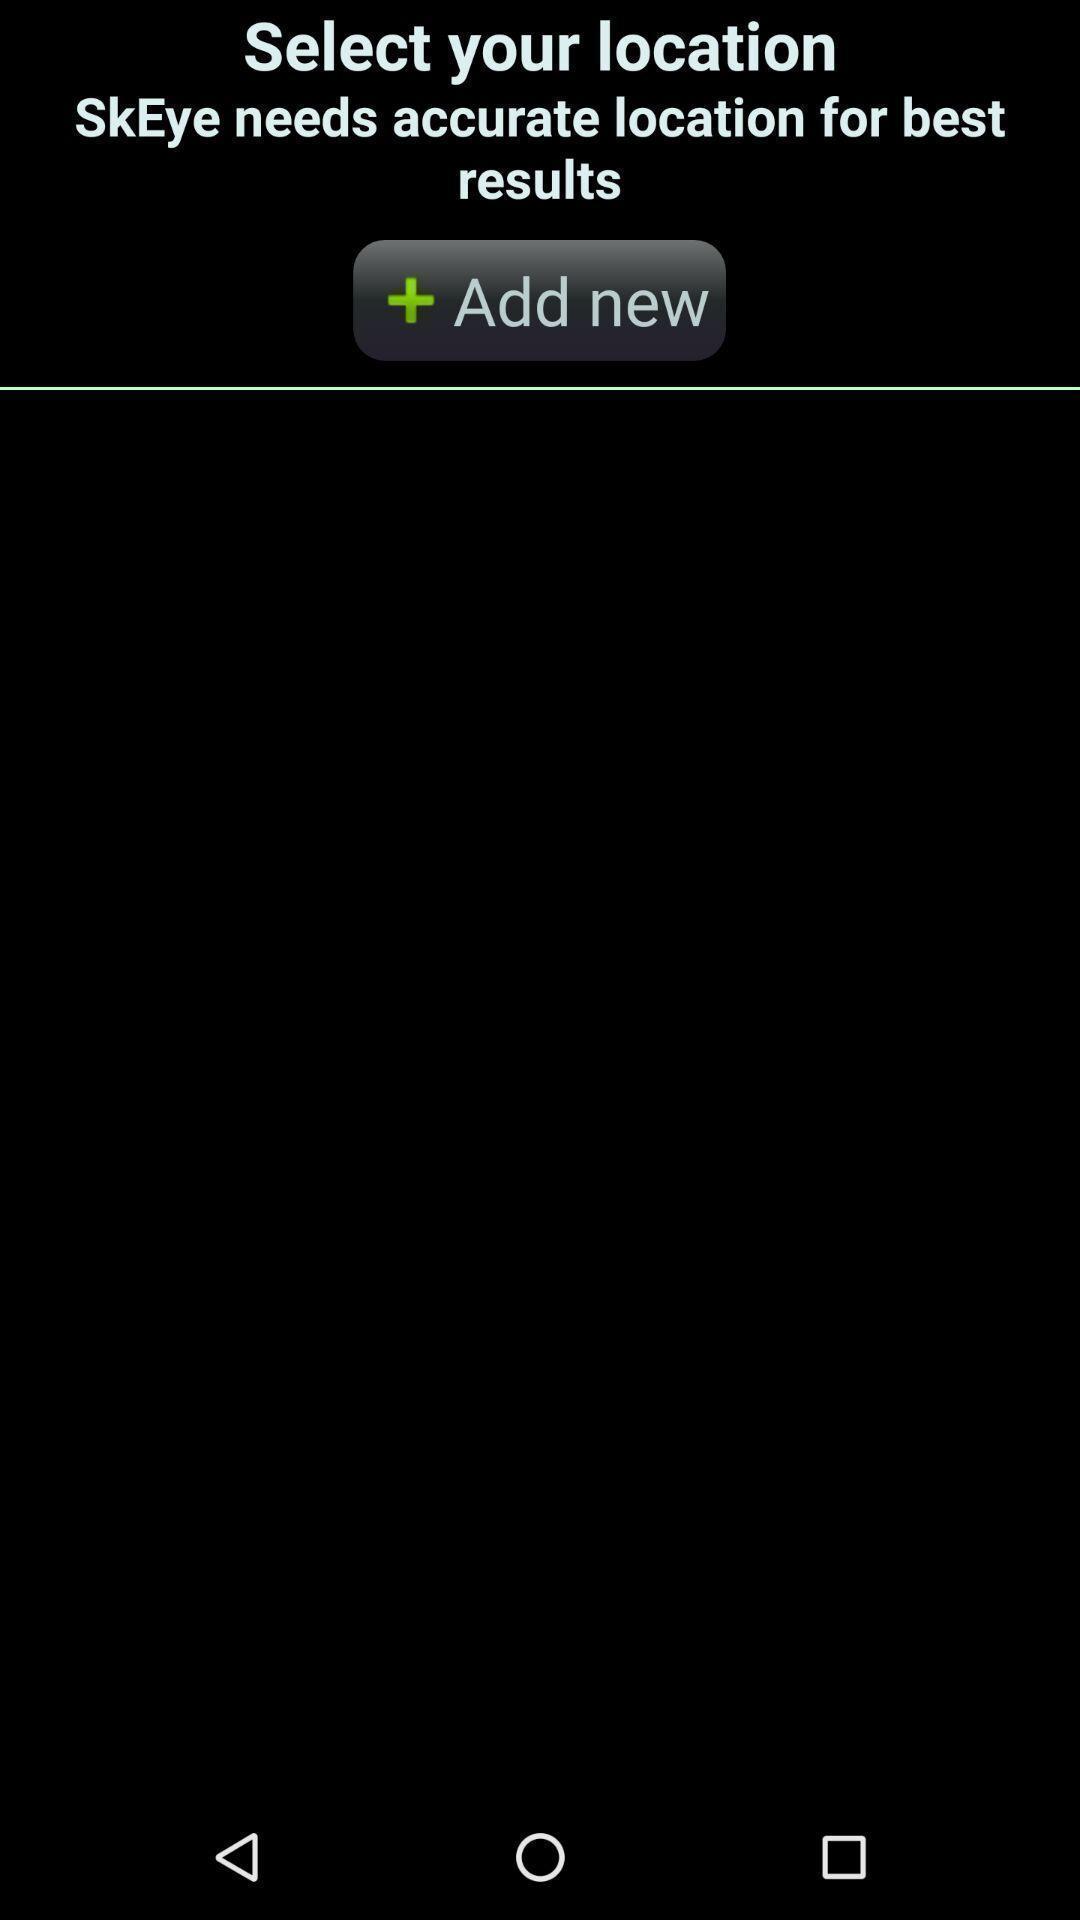What details can you identify in this image? Page to add new locations. 